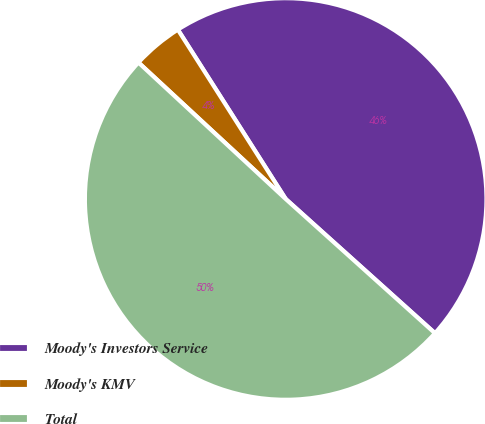<chart> <loc_0><loc_0><loc_500><loc_500><pie_chart><fcel>Moody's Investors Service<fcel>Moody's KMV<fcel>Total<nl><fcel>45.68%<fcel>4.08%<fcel>50.24%<nl></chart> 